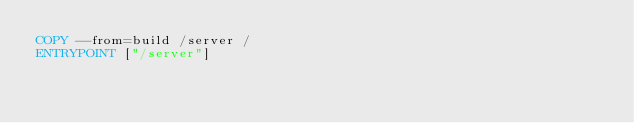Convert code to text. <code><loc_0><loc_0><loc_500><loc_500><_Dockerfile_>COPY --from=build /server /
ENTRYPOINT ["/server"]</code> 